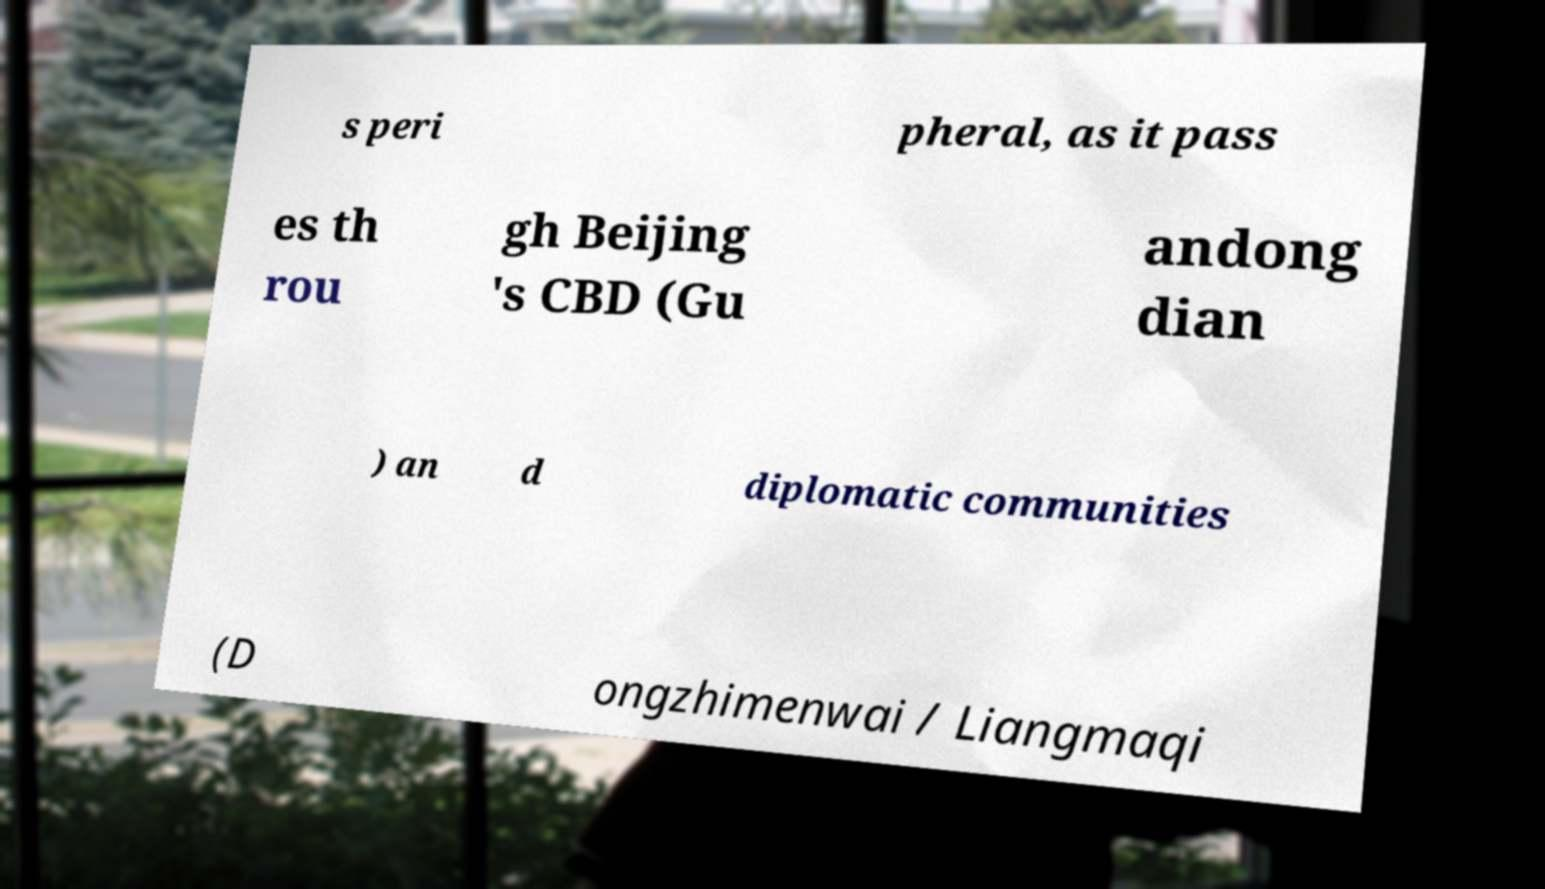Could you assist in decoding the text presented in this image and type it out clearly? s peri pheral, as it pass es th rou gh Beijing 's CBD (Gu andong dian ) an d diplomatic communities (D ongzhimenwai / Liangmaqi 